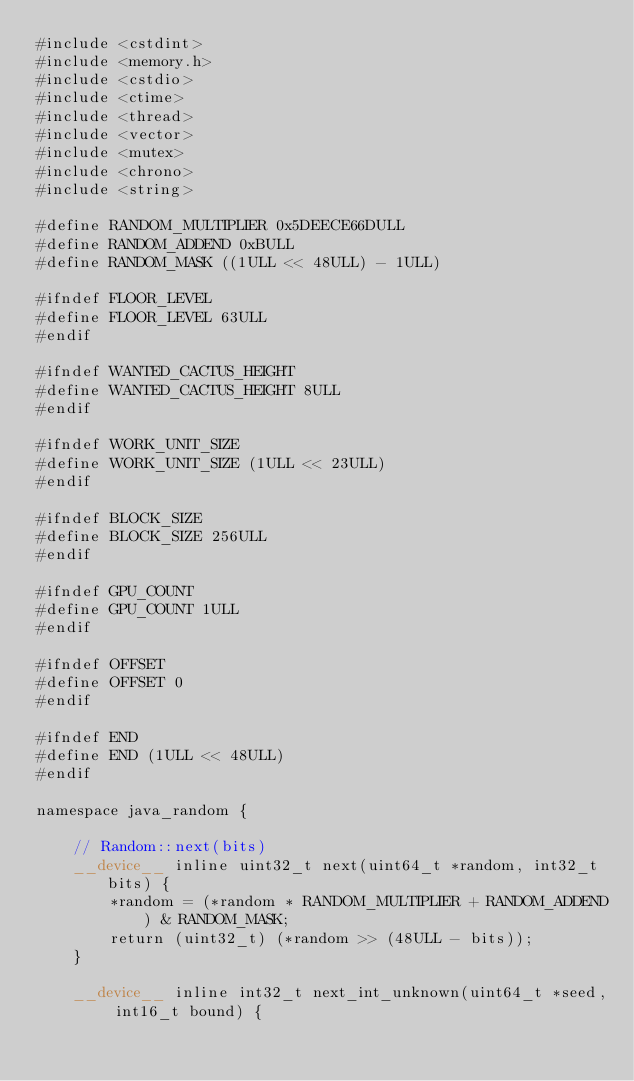Convert code to text. <code><loc_0><loc_0><loc_500><loc_500><_Cuda_>#include <cstdint>
#include <memory.h>
#include <cstdio>
#include <ctime>
#include <thread>
#include <vector>
#include <mutex>
#include <chrono>
#include <string>

#define RANDOM_MULTIPLIER 0x5DEECE66DULL
#define RANDOM_ADDEND 0xBULL
#define RANDOM_MASK ((1ULL << 48ULL) - 1ULL)

#ifndef FLOOR_LEVEL
#define FLOOR_LEVEL 63ULL
#endif

#ifndef WANTED_CACTUS_HEIGHT
#define WANTED_CACTUS_HEIGHT 8ULL
#endif

#ifndef WORK_UNIT_SIZE
#define WORK_UNIT_SIZE (1ULL << 23ULL)
#endif

#ifndef BLOCK_SIZE
#define BLOCK_SIZE 256ULL
#endif

#ifndef GPU_COUNT
#define GPU_COUNT 1ULL
#endif

#ifndef OFFSET
#define OFFSET 0
#endif

#ifndef END
#define END (1ULL << 48ULL)
#endif

namespace java_random {

    // Random::next(bits)
    __device__ inline uint32_t next(uint64_t *random, int32_t bits) {
        *random = (*random * RANDOM_MULTIPLIER + RANDOM_ADDEND) & RANDOM_MASK;
        return (uint32_t) (*random >> (48ULL - bits));
    }

    __device__ inline int32_t next_int_unknown(uint64_t *seed, int16_t bound) {</code> 